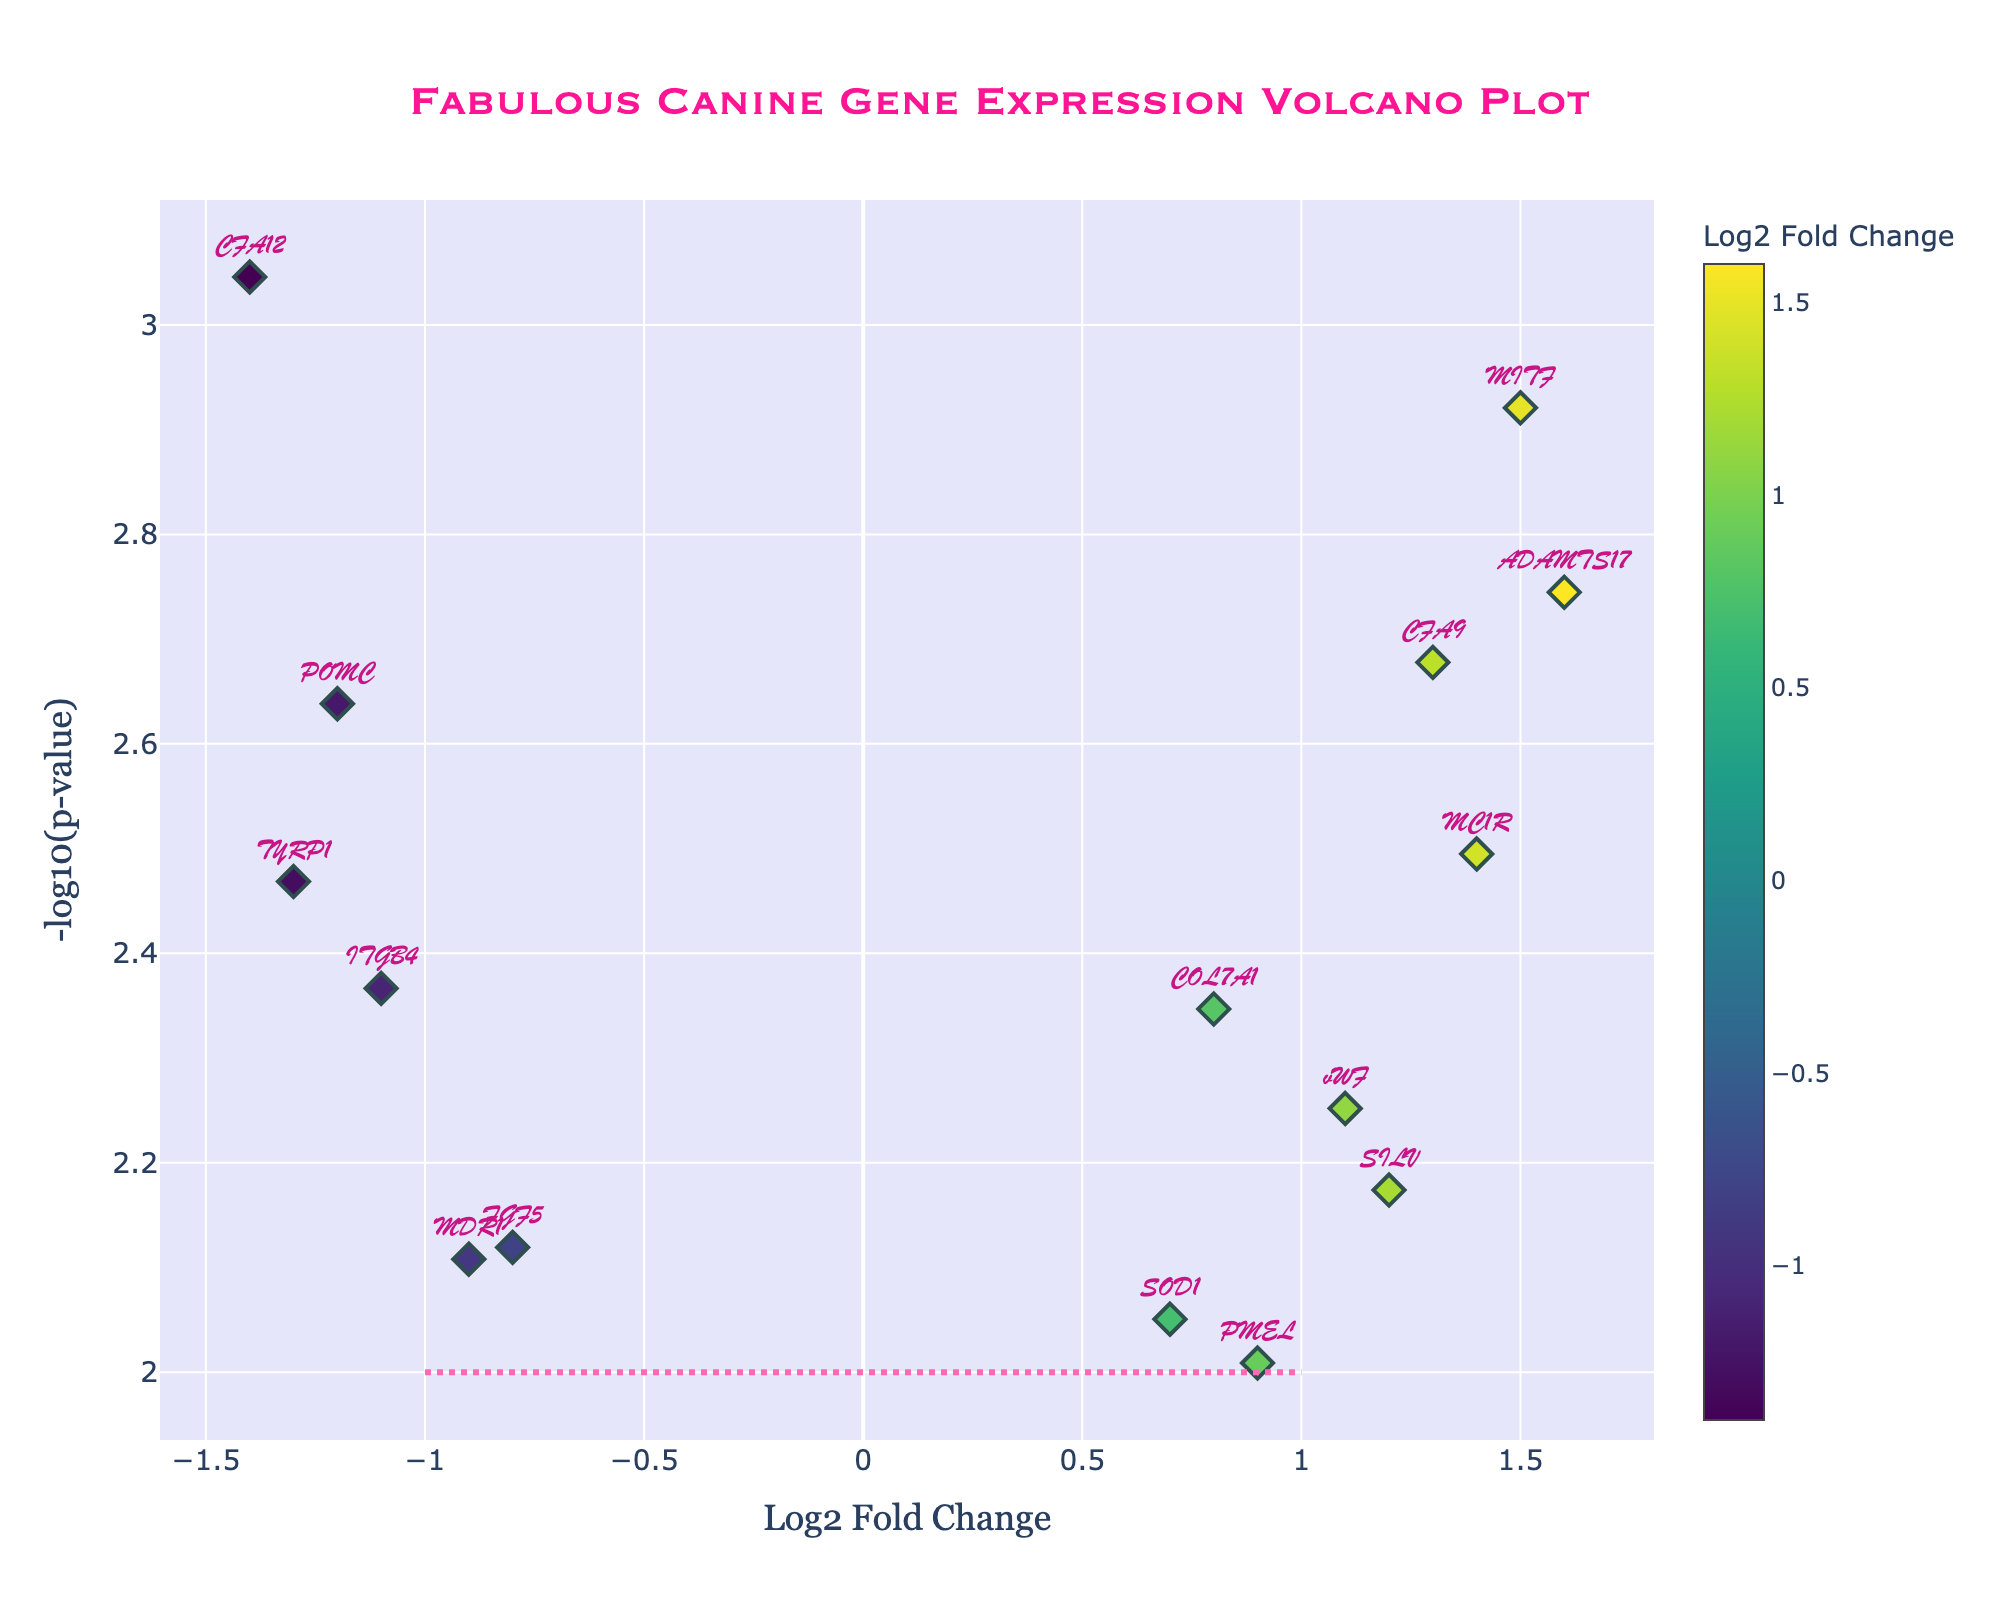What is the title of the plot? The title of the plot is displayed prominently at the top center. By reading it, you can see the title is "Fabulous Canine Gene Expression Volcano Plot".
Answer: Fabulous Canine Gene Expression Volcano Plot What is the x-axis labeled as? The x-axis label is positioned below the horizontal axis. It reads "Log2 Fold Change".
Answer: Log2 Fold Change Which gene has the smallest p-value? The gene with the smallest p-value will have the highest value on the y-axis. By checking the plot, you can see that CFA12 is at the highest y-axis position.
Answer: CFA12 How many genes have a negative log2 fold change? To find the genes with negative log2 fold change, look at the left half of the plot (negative x-axis). There are five points on the left side.
Answer: 5 Which gene shows the highest log2 fold change? The gene with the highest log2 fold change will be the one farthest to the right on the x-axis. ADAMTS17 is on the extremity of the right side.
Answer: ADAMTS17 Which two genes are closest in their log2 fold change values? Look at pairs of points that are close to each other horizontally. PMEL and FGF5 are very close to each other, around 0.9 and -0.8 respectively.
Answer: PMEL and FGF5 Which genes lie above the horizontal hot pink dashed line? The dashed line is drawn at y = 2. Genes above this line have a high statistical significance. The following genes lie above the line: CFA12, MITF, ADAMTS17, MC1R, POMC, CFA9, and TYRP1.
Answer: CFA12, MITF, ADAMTS17, MC1R, POMC, CFA9, TYRP1 What is the approximate -log10(p-value) for the gene vWF? To find the -log10(p-value) for vWF, locate it on the plot and read its y-axis value. It seems to be positioned just over 2.
Answer: Just over 2 Which gene has the largest negative log2 fold change? The largest negative log2 fold change will be the leftmost gene on the plot. CFA12 is the farthest left.
Answer: CFA12 